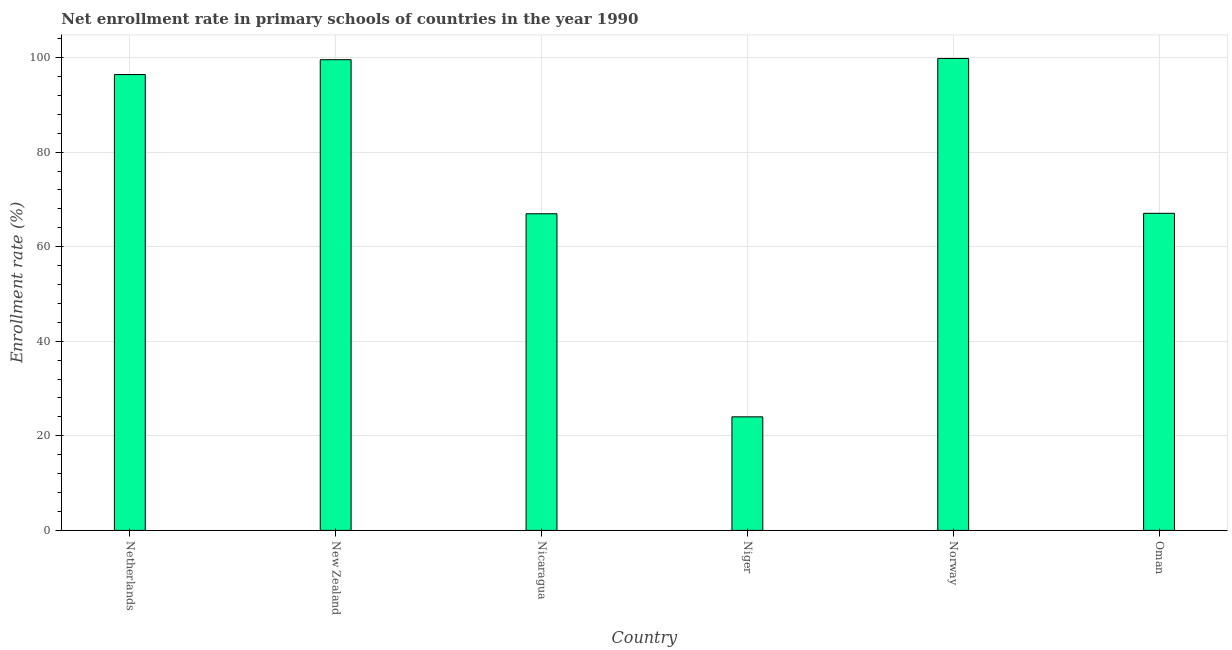Does the graph contain any zero values?
Give a very brief answer. No. What is the title of the graph?
Provide a short and direct response. Net enrollment rate in primary schools of countries in the year 1990. What is the label or title of the Y-axis?
Keep it short and to the point. Enrollment rate (%). What is the net enrollment rate in primary schools in Nicaragua?
Make the answer very short. 66.96. Across all countries, what is the maximum net enrollment rate in primary schools?
Offer a very short reply. 99.8. Across all countries, what is the minimum net enrollment rate in primary schools?
Ensure brevity in your answer.  24.01. In which country was the net enrollment rate in primary schools maximum?
Offer a very short reply. Norway. In which country was the net enrollment rate in primary schools minimum?
Provide a succinct answer. Niger. What is the sum of the net enrollment rate in primary schools?
Make the answer very short. 453.76. What is the difference between the net enrollment rate in primary schools in New Zealand and Niger?
Offer a very short reply. 75.53. What is the average net enrollment rate in primary schools per country?
Offer a terse response. 75.63. What is the median net enrollment rate in primary schools?
Give a very brief answer. 81.73. In how many countries, is the net enrollment rate in primary schools greater than 44 %?
Your answer should be compact. 5. What is the ratio of the net enrollment rate in primary schools in Niger to that in Norway?
Your answer should be very brief. 0.24. Is the net enrollment rate in primary schools in New Zealand less than that in Nicaragua?
Offer a terse response. No. What is the difference between the highest and the second highest net enrollment rate in primary schools?
Ensure brevity in your answer.  0.26. What is the difference between the highest and the lowest net enrollment rate in primary schools?
Provide a short and direct response. 75.79. Are all the bars in the graph horizontal?
Your answer should be compact. No. How many countries are there in the graph?
Ensure brevity in your answer.  6. What is the difference between two consecutive major ticks on the Y-axis?
Offer a very short reply. 20. Are the values on the major ticks of Y-axis written in scientific E-notation?
Ensure brevity in your answer.  No. What is the Enrollment rate (%) in Netherlands?
Provide a short and direct response. 96.4. What is the Enrollment rate (%) in New Zealand?
Provide a short and direct response. 99.54. What is the Enrollment rate (%) in Nicaragua?
Offer a terse response. 66.96. What is the Enrollment rate (%) of Niger?
Offer a terse response. 24.01. What is the Enrollment rate (%) in Norway?
Your response must be concise. 99.8. What is the Enrollment rate (%) of Oman?
Provide a succinct answer. 67.06. What is the difference between the Enrollment rate (%) in Netherlands and New Zealand?
Keep it short and to the point. -3.14. What is the difference between the Enrollment rate (%) in Netherlands and Nicaragua?
Your response must be concise. 29.44. What is the difference between the Enrollment rate (%) in Netherlands and Niger?
Ensure brevity in your answer.  72.39. What is the difference between the Enrollment rate (%) in Netherlands and Norway?
Provide a succinct answer. -3.4. What is the difference between the Enrollment rate (%) in Netherlands and Oman?
Offer a very short reply. 29.34. What is the difference between the Enrollment rate (%) in New Zealand and Nicaragua?
Make the answer very short. 32.58. What is the difference between the Enrollment rate (%) in New Zealand and Niger?
Your answer should be very brief. 75.53. What is the difference between the Enrollment rate (%) in New Zealand and Norway?
Offer a very short reply. -0.26. What is the difference between the Enrollment rate (%) in New Zealand and Oman?
Keep it short and to the point. 32.48. What is the difference between the Enrollment rate (%) in Nicaragua and Niger?
Keep it short and to the point. 42.95. What is the difference between the Enrollment rate (%) in Nicaragua and Norway?
Make the answer very short. -32.84. What is the difference between the Enrollment rate (%) in Nicaragua and Oman?
Give a very brief answer. -0.1. What is the difference between the Enrollment rate (%) in Niger and Norway?
Offer a terse response. -75.79. What is the difference between the Enrollment rate (%) in Niger and Oman?
Offer a terse response. -43.04. What is the difference between the Enrollment rate (%) in Norway and Oman?
Ensure brevity in your answer.  32.74. What is the ratio of the Enrollment rate (%) in Netherlands to that in New Zealand?
Offer a very short reply. 0.97. What is the ratio of the Enrollment rate (%) in Netherlands to that in Nicaragua?
Provide a succinct answer. 1.44. What is the ratio of the Enrollment rate (%) in Netherlands to that in Niger?
Your answer should be compact. 4.01. What is the ratio of the Enrollment rate (%) in Netherlands to that in Oman?
Ensure brevity in your answer.  1.44. What is the ratio of the Enrollment rate (%) in New Zealand to that in Nicaragua?
Keep it short and to the point. 1.49. What is the ratio of the Enrollment rate (%) in New Zealand to that in Niger?
Your response must be concise. 4.14. What is the ratio of the Enrollment rate (%) in New Zealand to that in Norway?
Offer a very short reply. 1. What is the ratio of the Enrollment rate (%) in New Zealand to that in Oman?
Offer a very short reply. 1.48. What is the ratio of the Enrollment rate (%) in Nicaragua to that in Niger?
Keep it short and to the point. 2.79. What is the ratio of the Enrollment rate (%) in Nicaragua to that in Norway?
Give a very brief answer. 0.67. What is the ratio of the Enrollment rate (%) in Nicaragua to that in Oman?
Offer a terse response. 1. What is the ratio of the Enrollment rate (%) in Niger to that in Norway?
Provide a succinct answer. 0.24. What is the ratio of the Enrollment rate (%) in Niger to that in Oman?
Give a very brief answer. 0.36. What is the ratio of the Enrollment rate (%) in Norway to that in Oman?
Give a very brief answer. 1.49. 